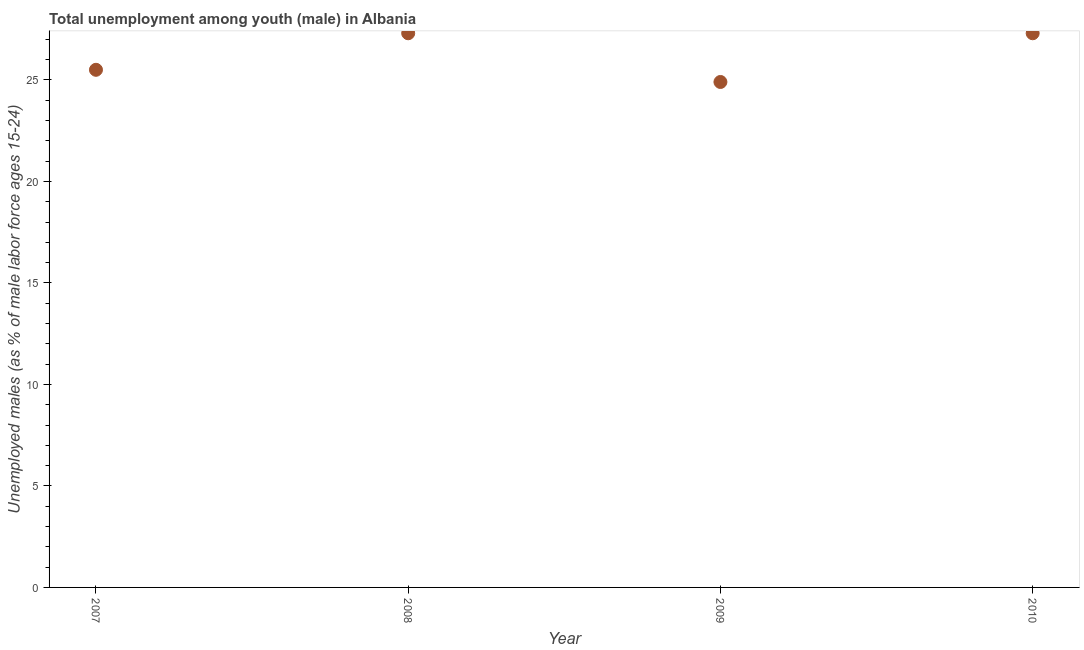What is the unemployed male youth population in 2010?
Your answer should be very brief. 27.3. Across all years, what is the maximum unemployed male youth population?
Your answer should be very brief. 27.3. Across all years, what is the minimum unemployed male youth population?
Provide a succinct answer. 24.9. In which year was the unemployed male youth population maximum?
Provide a short and direct response. 2008. What is the sum of the unemployed male youth population?
Offer a terse response. 105. What is the difference between the unemployed male youth population in 2008 and 2010?
Make the answer very short. 0. What is the average unemployed male youth population per year?
Ensure brevity in your answer.  26.25. What is the median unemployed male youth population?
Ensure brevity in your answer.  26.4. What is the ratio of the unemployed male youth population in 2009 to that in 2010?
Make the answer very short. 0.91. Is the difference between the unemployed male youth population in 2009 and 2010 greater than the difference between any two years?
Offer a very short reply. Yes. Is the sum of the unemployed male youth population in 2009 and 2010 greater than the maximum unemployed male youth population across all years?
Offer a terse response. Yes. What is the difference between the highest and the lowest unemployed male youth population?
Keep it short and to the point. 2.4. In how many years, is the unemployed male youth population greater than the average unemployed male youth population taken over all years?
Offer a terse response. 2. How many years are there in the graph?
Keep it short and to the point. 4. Are the values on the major ticks of Y-axis written in scientific E-notation?
Keep it short and to the point. No. Does the graph contain any zero values?
Ensure brevity in your answer.  No. What is the title of the graph?
Provide a short and direct response. Total unemployment among youth (male) in Albania. What is the label or title of the Y-axis?
Offer a terse response. Unemployed males (as % of male labor force ages 15-24). What is the Unemployed males (as % of male labor force ages 15-24) in 2008?
Your answer should be compact. 27.3. What is the Unemployed males (as % of male labor force ages 15-24) in 2009?
Give a very brief answer. 24.9. What is the Unemployed males (as % of male labor force ages 15-24) in 2010?
Ensure brevity in your answer.  27.3. What is the difference between the Unemployed males (as % of male labor force ages 15-24) in 2008 and 2009?
Keep it short and to the point. 2.4. What is the difference between the Unemployed males (as % of male labor force ages 15-24) in 2008 and 2010?
Ensure brevity in your answer.  0. What is the difference between the Unemployed males (as % of male labor force ages 15-24) in 2009 and 2010?
Ensure brevity in your answer.  -2.4. What is the ratio of the Unemployed males (as % of male labor force ages 15-24) in 2007 to that in 2008?
Offer a very short reply. 0.93. What is the ratio of the Unemployed males (as % of male labor force ages 15-24) in 2007 to that in 2010?
Your answer should be compact. 0.93. What is the ratio of the Unemployed males (as % of male labor force ages 15-24) in 2008 to that in 2009?
Provide a short and direct response. 1.1. What is the ratio of the Unemployed males (as % of male labor force ages 15-24) in 2009 to that in 2010?
Your response must be concise. 0.91. 